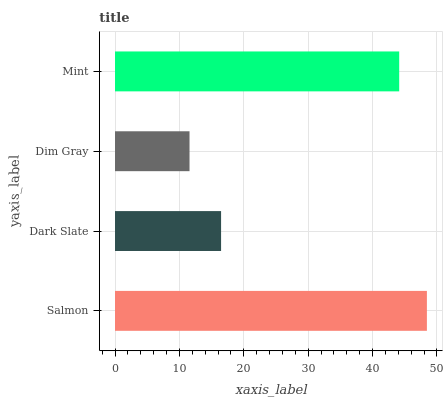Is Dim Gray the minimum?
Answer yes or no. Yes. Is Salmon the maximum?
Answer yes or no. Yes. Is Dark Slate the minimum?
Answer yes or no. No. Is Dark Slate the maximum?
Answer yes or no. No. Is Salmon greater than Dark Slate?
Answer yes or no. Yes. Is Dark Slate less than Salmon?
Answer yes or no. Yes. Is Dark Slate greater than Salmon?
Answer yes or no. No. Is Salmon less than Dark Slate?
Answer yes or no. No. Is Mint the high median?
Answer yes or no. Yes. Is Dark Slate the low median?
Answer yes or no. Yes. Is Salmon the high median?
Answer yes or no. No. Is Mint the low median?
Answer yes or no. No. 